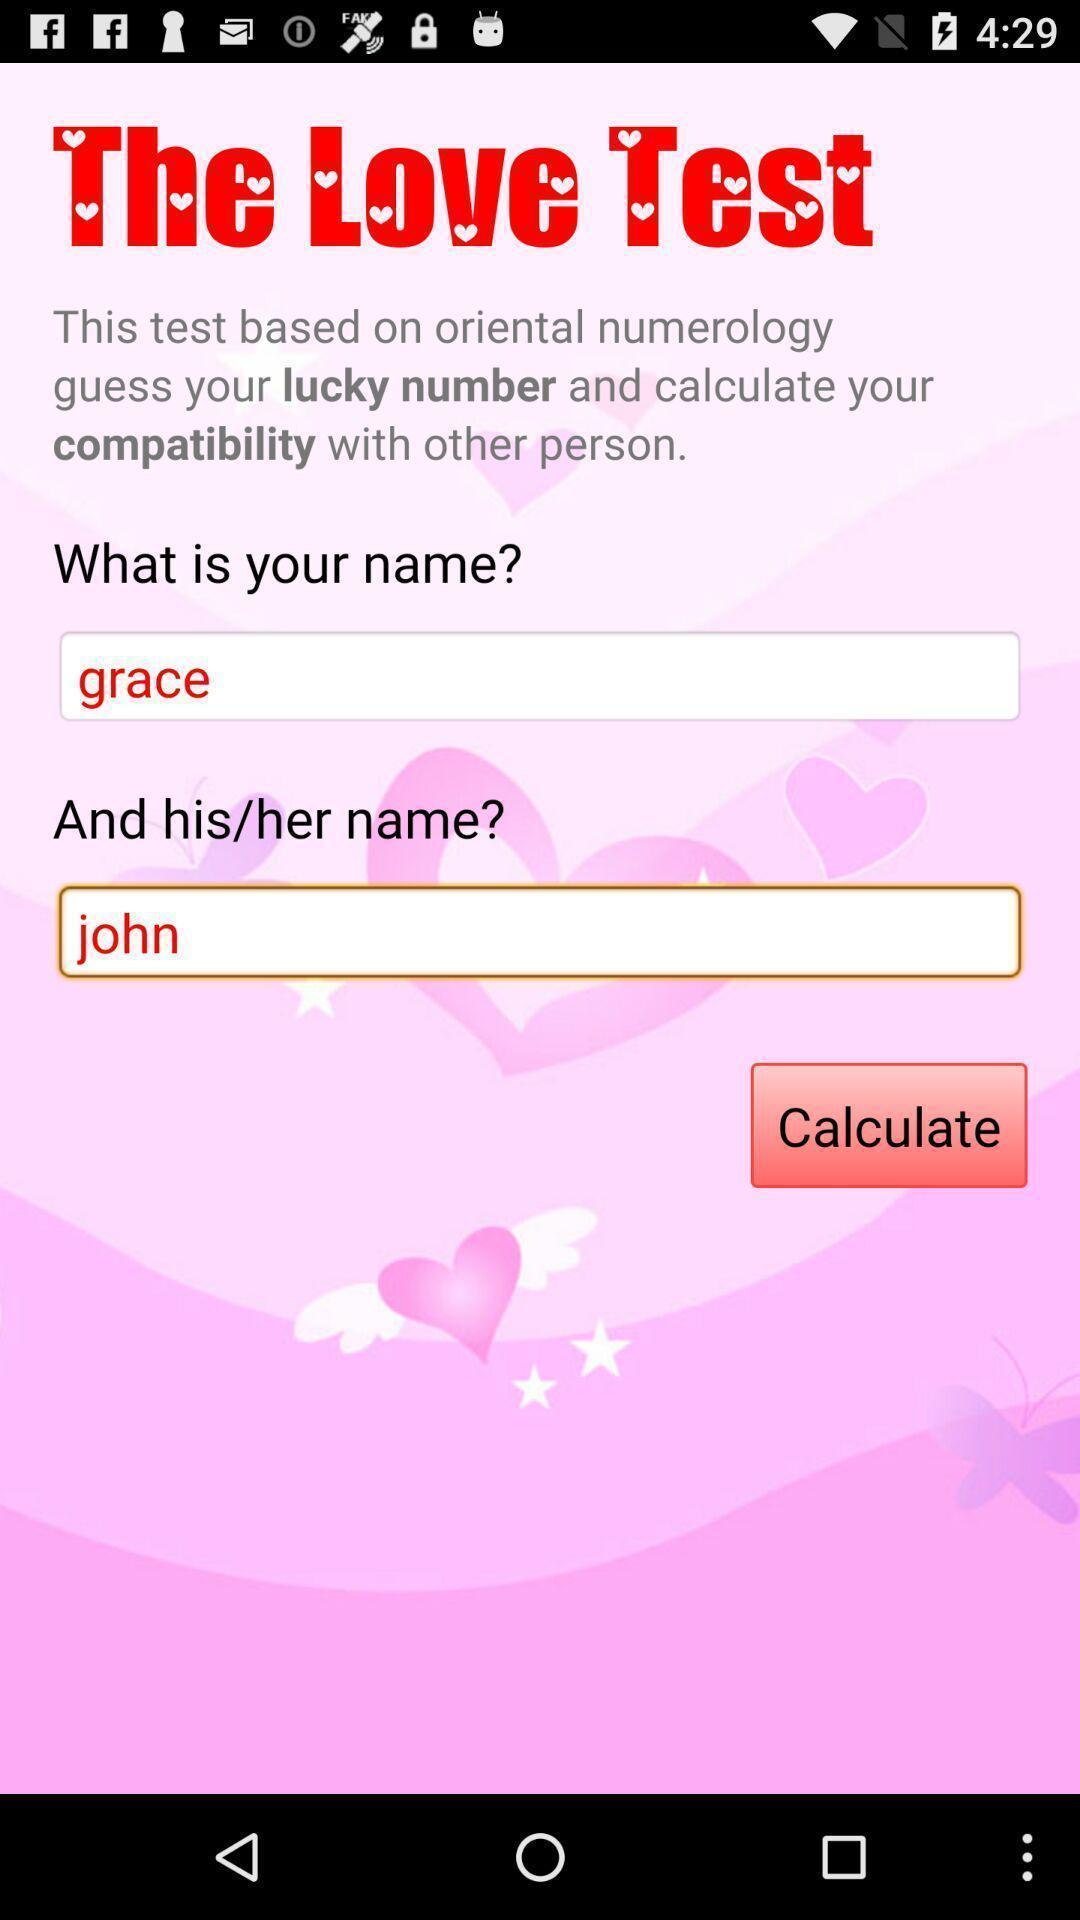Give me a narrative description of this picture. Welcome page of a love calculator app. 